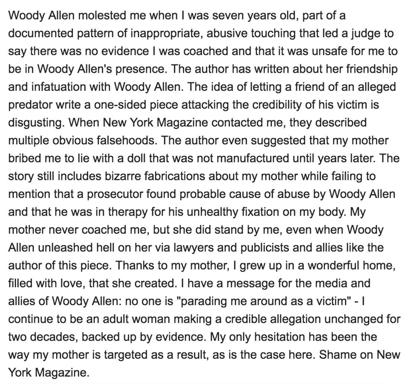What implications might the author's statement have on public perceptions of celebrity accusations? The author's statement might influence public perceptions by highlighting issues of media bias and the complexity surrounding accusations against celebrities.  It suggests a need for a more nuanced, evidence-based approach when discussing such sensitive matters publicly and in the media. And how might this influence media practices? This could potentially lead to more rigorous journalistic standards, where media outlets are compelled to investigate thoroughly and avoid one-sided narratives. It advocates for accountability in reporting, especially in high-profile cases to prevent the dissemination of misinformation. 